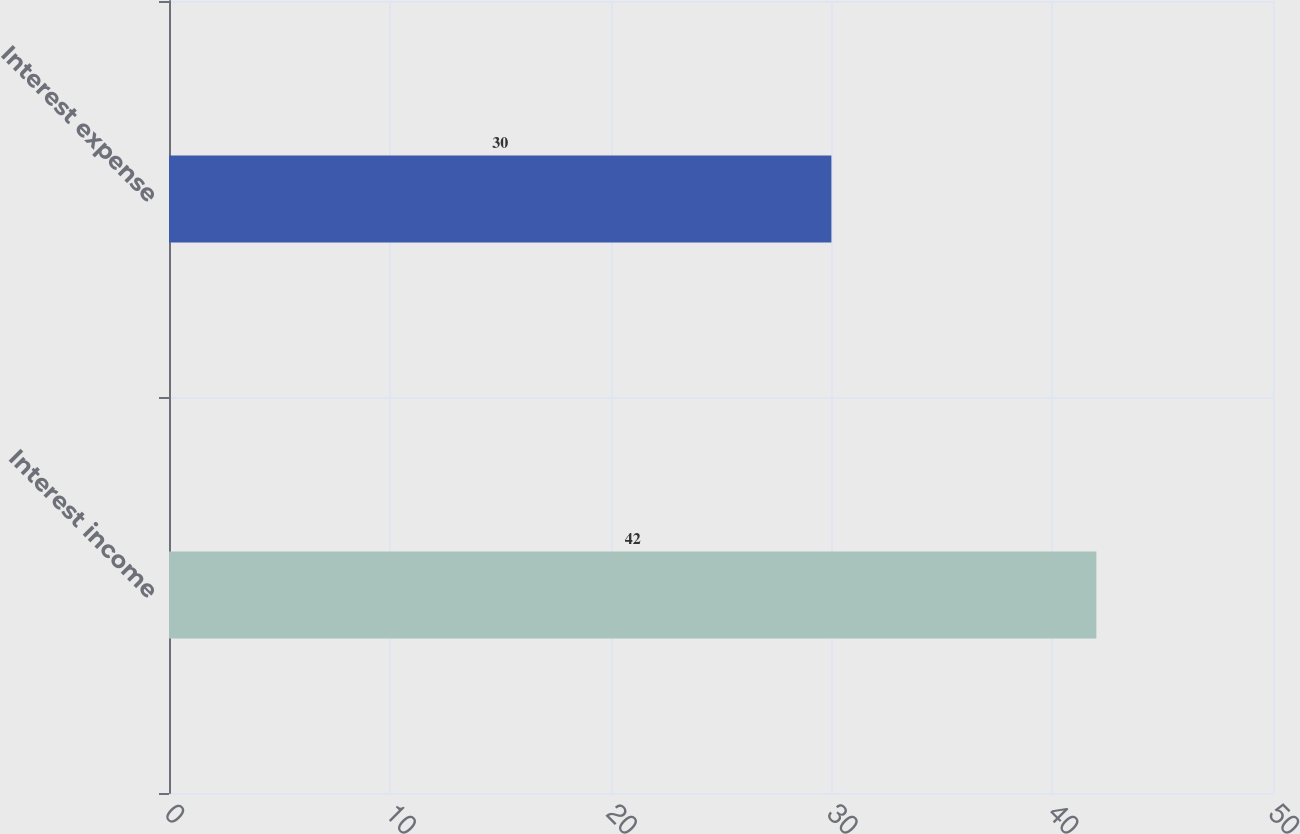<chart> <loc_0><loc_0><loc_500><loc_500><bar_chart><fcel>Interest income<fcel>Interest expense<nl><fcel>42<fcel>30<nl></chart> 